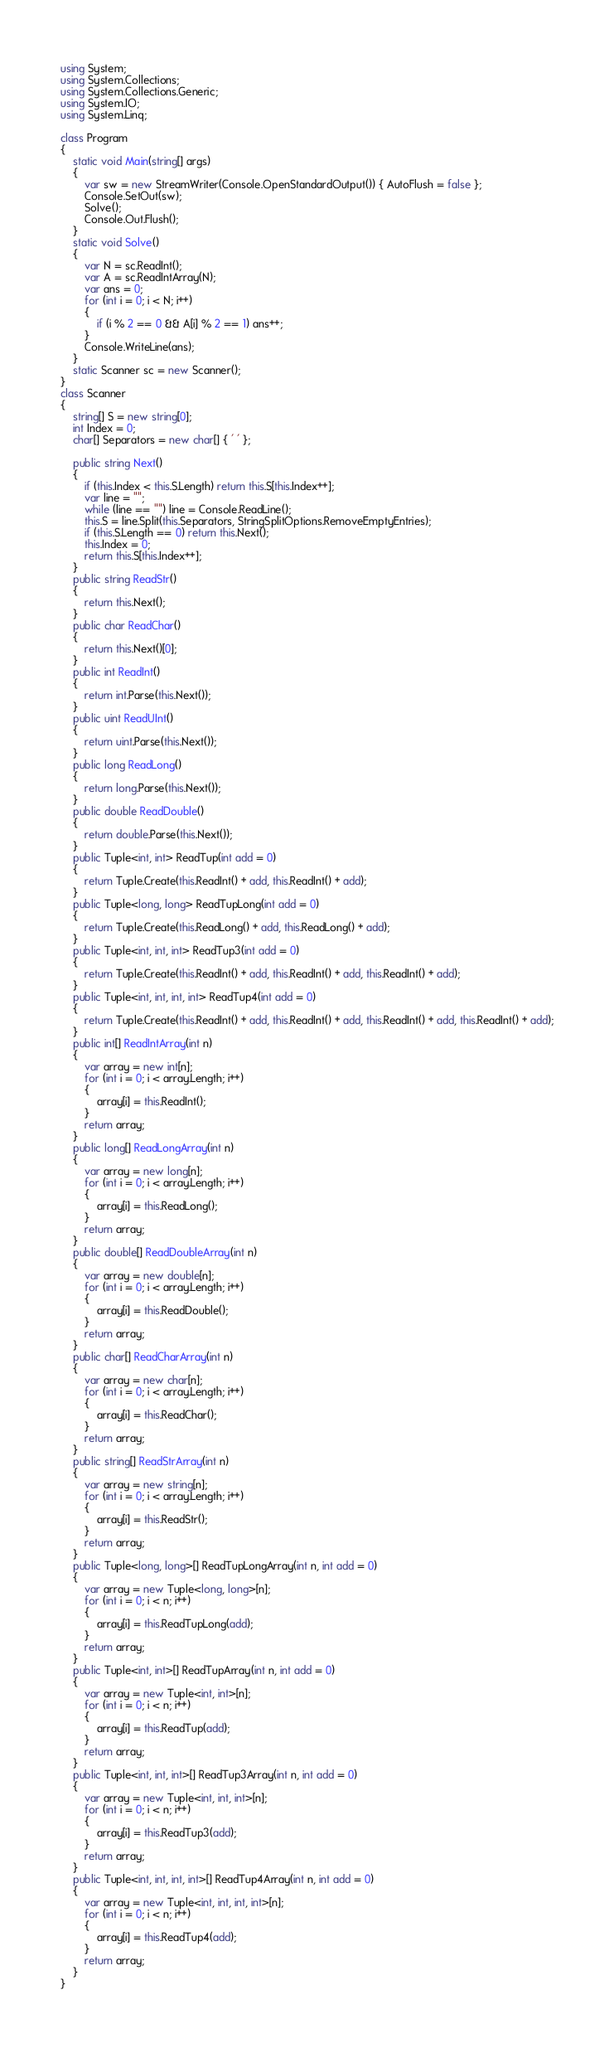Convert code to text. <code><loc_0><loc_0><loc_500><loc_500><_C#_>using System;
using System.Collections;
using System.Collections.Generic;
using System.IO;
using System.Linq;

class Program
{
    static void Main(string[] args)
    {
        var sw = new StreamWriter(Console.OpenStandardOutput()) { AutoFlush = false };
        Console.SetOut(sw);
        Solve();
        Console.Out.Flush();
    }
    static void Solve()
    {
        var N = sc.ReadInt();
        var A = sc.ReadIntArray(N);
        var ans = 0;
        for (int i = 0; i < N; i++)
        {
            if (i % 2 == 0 && A[i] % 2 == 1) ans++;
        }
        Console.WriteLine(ans);
    }
    static Scanner sc = new Scanner();
}
class Scanner
{
    string[] S = new string[0];
    int Index = 0;
    char[] Separators = new char[] { ' ' };

    public string Next()
    {
        if (this.Index < this.S.Length) return this.S[this.Index++];
        var line = "";
        while (line == "") line = Console.ReadLine();
        this.S = line.Split(this.Separators, StringSplitOptions.RemoveEmptyEntries);
        if (this.S.Length == 0) return this.Next();
        this.Index = 0;
        return this.S[this.Index++];
    }
    public string ReadStr()
    {
        return this.Next();
    }
    public char ReadChar()
    {
        return this.Next()[0];
    }
    public int ReadInt()
    {
        return int.Parse(this.Next());
    }
    public uint ReadUInt()
    {
        return uint.Parse(this.Next());
    }
    public long ReadLong()
    {
        return long.Parse(this.Next());
    }
    public double ReadDouble()
    {
        return double.Parse(this.Next());
    }
    public Tuple<int, int> ReadTup(int add = 0)
    {
        return Tuple.Create(this.ReadInt() + add, this.ReadInt() + add);
    }
    public Tuple<long, long> ReadTupLong(int add = 0)
    {
        return Tuple.Create(this.ReadLong() + add, this.ReadLong() + add);
    }
    public Tuple<int, int, int> ReadTup3(int add = 0)
    {
        return Tuple.Create(this.ReadInt() + add, this.ReadInt() + add, this.ReadInt() + add);
    }
    public Tuple<int, int, int, int> ReadTup4(int add = 0)
    {
        return Tuple.Create(this.ReadInt() + add, this.ReadInt() + add, this.ReadInt() + add, this.ReadInt() + add);
    }
    public int[] ReadIntArray(int n)
    {
        var array = new int[n];
        for (int i = 0; i < array.Length; i++)
        {
            array[i] = this.ReadInt();
        }
        return array;
    }
    public long[] ReadLongArray(int n)
    {
        var array = new long[n];
        for (int i = 0; i < array.Length; i++)
        {
            array[i] = this.ReadLong();
        }
        return array;
    }
    public double[] ReadDoubleArray(int n)
    {
        var array = new double[n];
        for (int i = 0; i < array.Length; i++)
        {
            array[i] = this.ReadDouble();
        }
        return array;
    }
    public char[] ReadCharArray(int n)
    {
        var array = new char[n];
        for (int i = 0; i < array.Length; i++)
        {
            array[i] = this.ReadChar();
        }
        return array;
    }
    public string[] ReadStrArray(int n)
    {
        var array = new string[n];
        for (int i = 0; i < array.Length; i++)
        {
            array[i] = this.ReadStr();
        }
        return array;
    }
    public Tuple<long, long>[] ReadTupLongArray(int n, int add = 0)
    {
        var array = new Tuple<long, long>[n];
        for (int i = 0; i < n; i++)
        {
            array[i] = this.ReadTupLong(add);
        }
        return array;
    }
    public Tuple<int, int>[] ReadTupArray(int n, int add = 0)
    {
        var array = new Tuple<int, int>[n];
        for (int i = 0; i < n; i++)
        {
            array[i] = this.ReadTup(add);
        }
        return array;
    }
    public Tuple<int, int, int>[] ReadTup3Array(int n, int add = 0)
    {
        var array = new Tuple<int, int, int>[n];
        for (int i = 0; i < n; i++)
        {
            array[i] = this.ReadTup3(add);
        }
        return array;
    }
    public Tuple<int, int, int, int>[] ReadTup4Array(int n, int add = 0)
    {
        var array = new Tuple<int, int, int, int>[n];
        for (int i = 0; i < n; i++)
        {
            array[i] = this.ReadTup4(add);
        }
        return array;
    }
}
</code> 